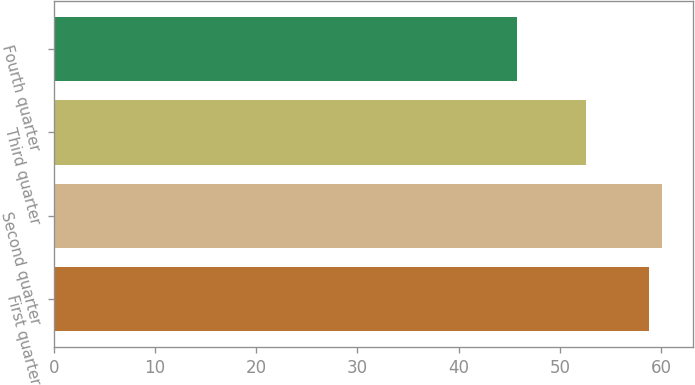<chart> <loc_0><loc_0><loc_500><loc_500><bar_chart><fcel>First quarter<fcel>Second quarter<fcel>Third quarter<fcel>Fourth quarter<nl><fcel>58.78<fcel>60.09<fcel>52.55<fcel>45.8<nl></chart> 